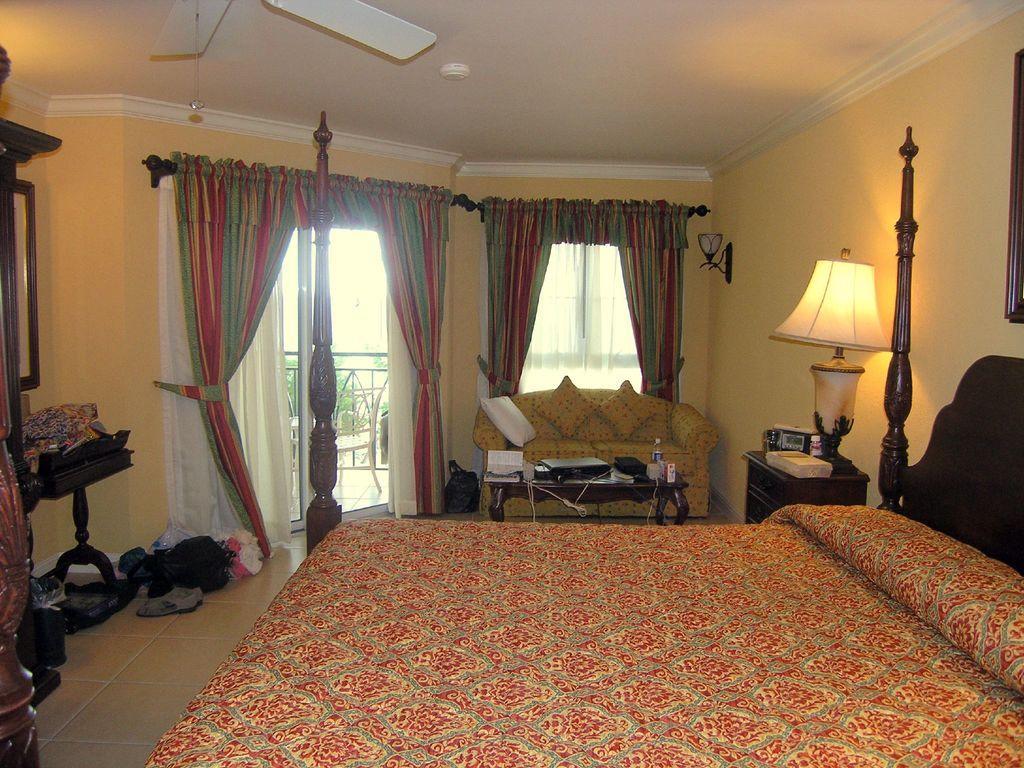Can you describe this image briefly? The picture is taken inside a room. There is bed with a printed bed cover. In the background there is curtains,windows, a sofa is there. In front of it there is a table on that table there is some books,bottle and some stuff. Beside the bed there is a table. On that there is a table lamp is there. On the left side there is a mirror. Beside it there are some clothes and shoes. On the top there is fan. 